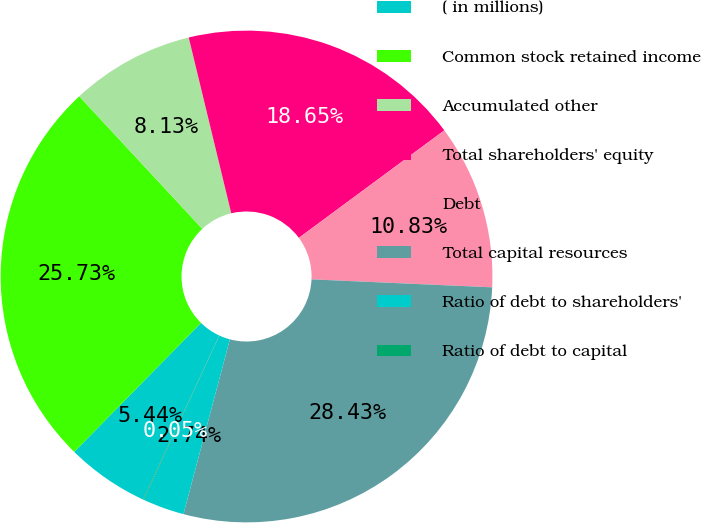Convert chart to OTSL. <chart><loc_0><loc_0><loc_500><loc_500><pie_chart><fcel>( in millions)<fcel>Common stock retained income<fcel>Accumulated other<fcel>Total shareholders' equity<fcel>Debt<fcel>Total capital resources<fcel>Ratio of debt to shareholders'<fcel>Ratio of debt to capital<nl><fcel>5.44%<fcel>25.73%<fcel>8.13%<fcel>18.65%<fcel>10.83%<fcel>28.43%<fcel>2.74%<fcel>0.05%<nl></chart> 